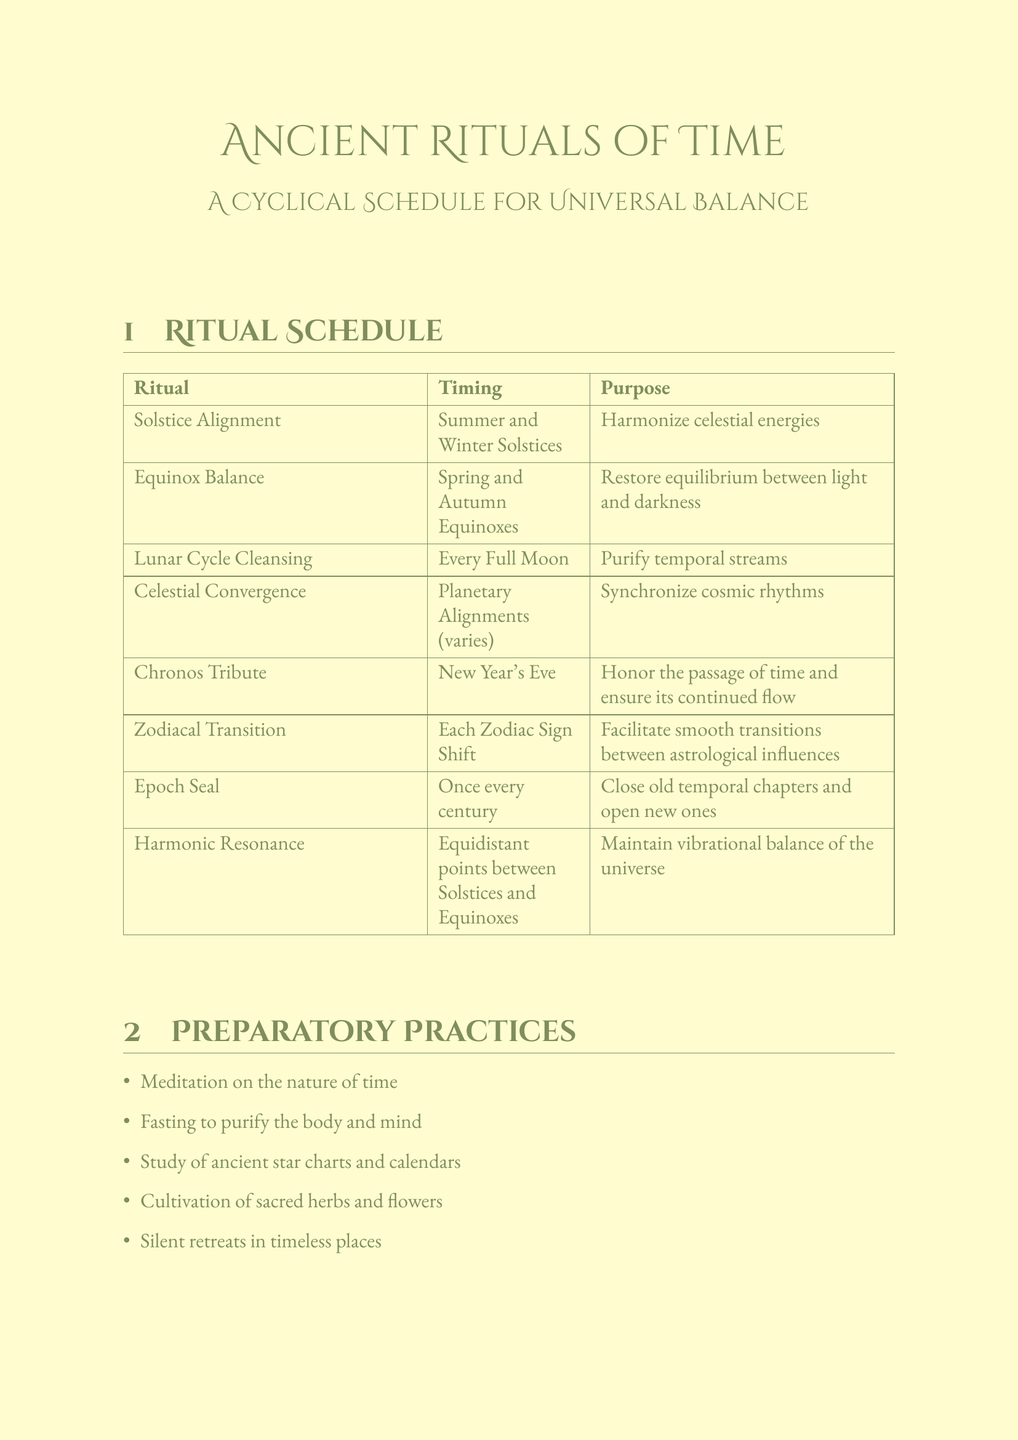What is the purpose of the Solstice Alignment? The purpose of the Solstice Alignment is to harmonize celestial energies.
Answer: Harmonize celestial energies Where is the Lunar Cycle Cleansing held? The location for the Lunar Cycle Cleansing is Mount Kailash, Tibet.
Answer: Mount Kailash, Tibet How often is the Epoch Seal performed? The Epoch Seal is performed once every century.
Answer: Once every century What elements are used in the Equinox Balance? The elements used in the Equinox Balance include scales of Ma'at, white and black candles, and an hourglass.
Answer: Scales of Ma'at, white and black candles, hourglass Which ritual occurs on New Year's Eve? The ritual that occurs on New Year's Eve is the Chronos Tribute.
Answer: Chronos Tribute What is the Law of Rhythm? The Law of Rhythm states that everything has its tides, its ebb and flow, its rise and fall.
Answer: Everything has its tides, its ebb and flow, its rise and fall Name one participant in the Zodiacal Transition. One participant in the Zodiacal Transition is the Celestial Scribes.
Answer: Celestial Scribes What are preparatory practices intended for? Preparatory practices are intended to prepare participants for the rituals.
Answer: Prepare participants for the rituals How many rituals are listed in the document? There are eight rituals listed in the document.
Answer: Eight 